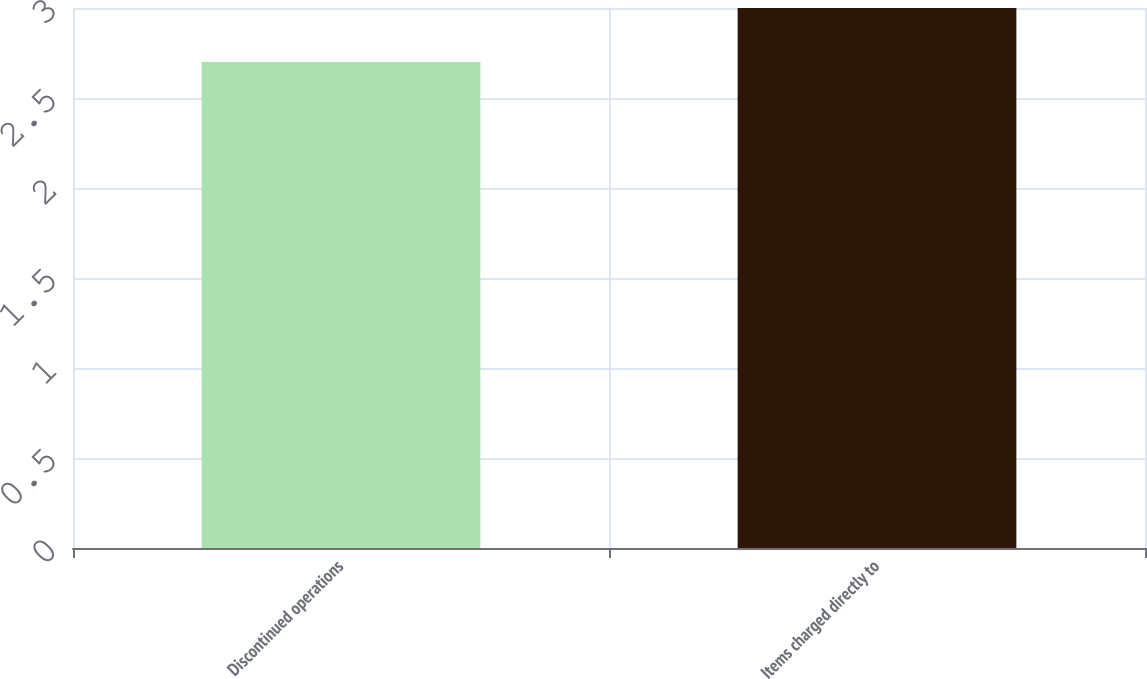Convert chart to OTSL. <chart><loc_0><loc_0><loc_500><loc_500><bar_chart><fcel>Discontinued operations<fcel>Items charged directly to<nl><fcel>2.7<fcel>3<nl></chart> 